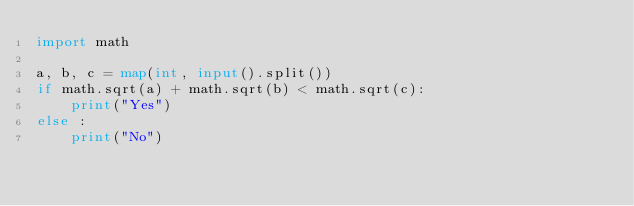<code> <loc_0><loc_0><loc_500><loc_500><_Python_>import math

a, b, c = map(int, input().split())
if math.sqrt(a) + math.sqrt(b) < math.sqrt(c):
    print("Yes")
else :
    print("No")</code> 